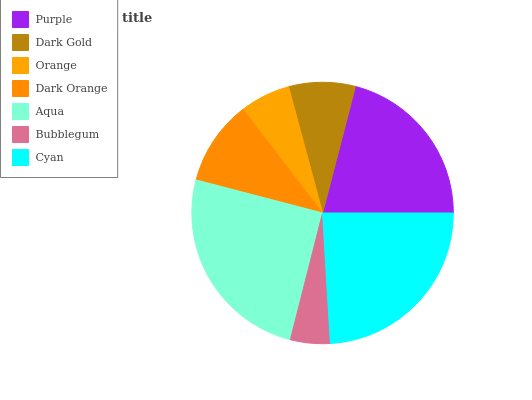Is Bubblegum the minimum?
Answer yes or no. Yes. Is Aqua the maximum?
Answer yes or no. Yes. Is Dark Gold the minimum?
Answer yes or no. No. Is Dark Gold the maximum?
Answer yes or no. No. Is Purple greater than Dark Gold?
Answer yes or no. Yes. Is Dark Gold less than Purple?
Answer yes or no. Yes. Is Dark Gold greater than Purple?
Answer yes or no. No. Is Purple less than Dark Gold?
Answer yes or no. No. Is Dark Orange the high median?
Answer yes or no. Yes. Is Dark Orange the low median?
Answer yes or no. Yes. Is Bubblegum the high median?
Answer yes or no. No. Is Dark Gold the low median?
Answer yes or no. No. 